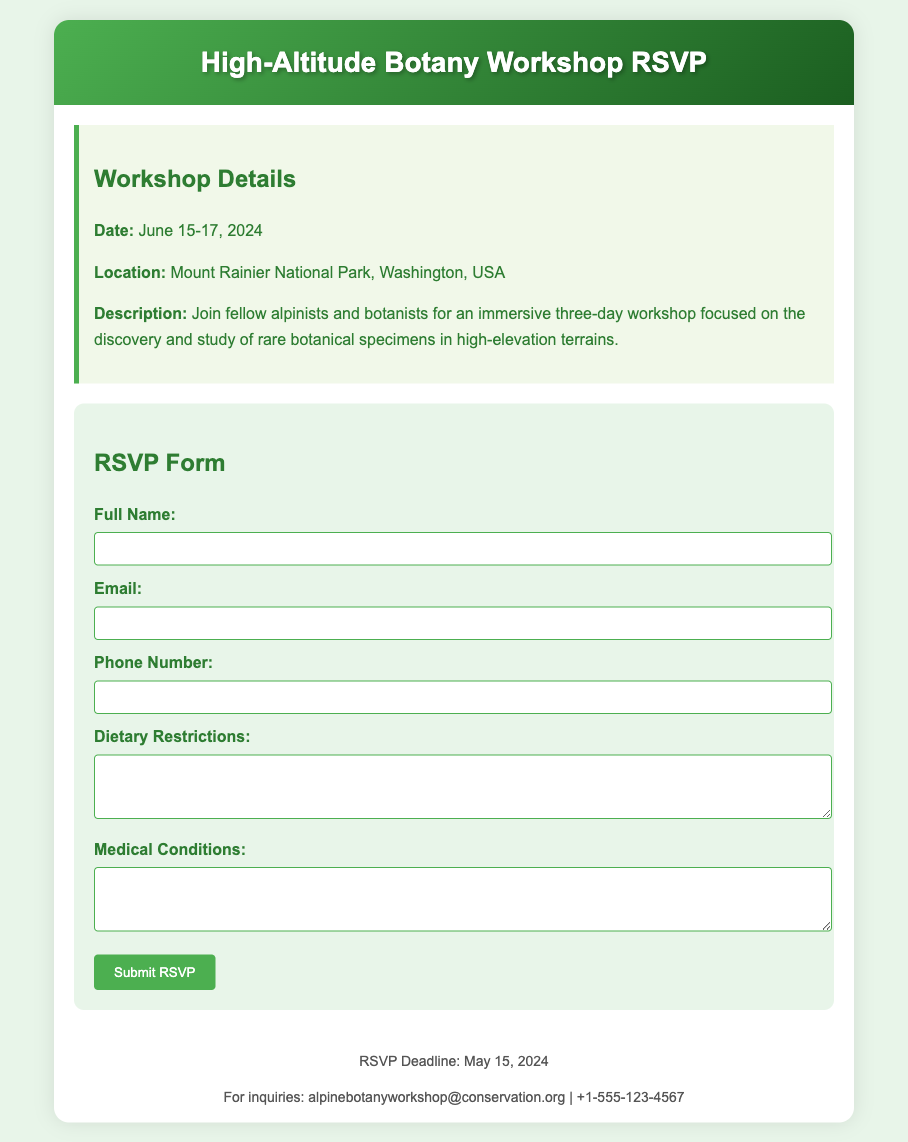What are the dates of the workshop? The workshop is scheduled for June 15-17, 2024, as stated in the document.
Answer: June 15-17, 2024 Where is the workshop located? The location of the workshop is provided, which is Mount Rainier National Park, Washington, USA.
Answer: Mount Rainier National Park, Washington, USA What is the RSVP deadline? The document specifies the RSVP deadline as May 15, 2024.
Answer: May 15, 2024 What is the main focus of the workshop? The description outlines that the workshop focuses on the discovery and study of rare botanical specimens in high-elevation terrains.
Answer: Discovery and study of rare botanical specimens What should attendees provide if they have dietary restrictions? The RSVP form includes a section asking for dietary restrictions in a textarea.
Answer: Dietary Restrictions What is the contact email for inquiries? The footer of the document lists the contact email for inquiries as alpinebotanyworkshop@conservation.org.
Answer: alpinebotanyworkshop@conservation.org What type of event is this document for? The document is an RSVP card, which is specific to gathering responses for events.
Answer: RSVP card What should participants include regarding medical conditions? Participants are asked to provide information on medical conditions in the RSVP form.
Answer: Medical Conditions 